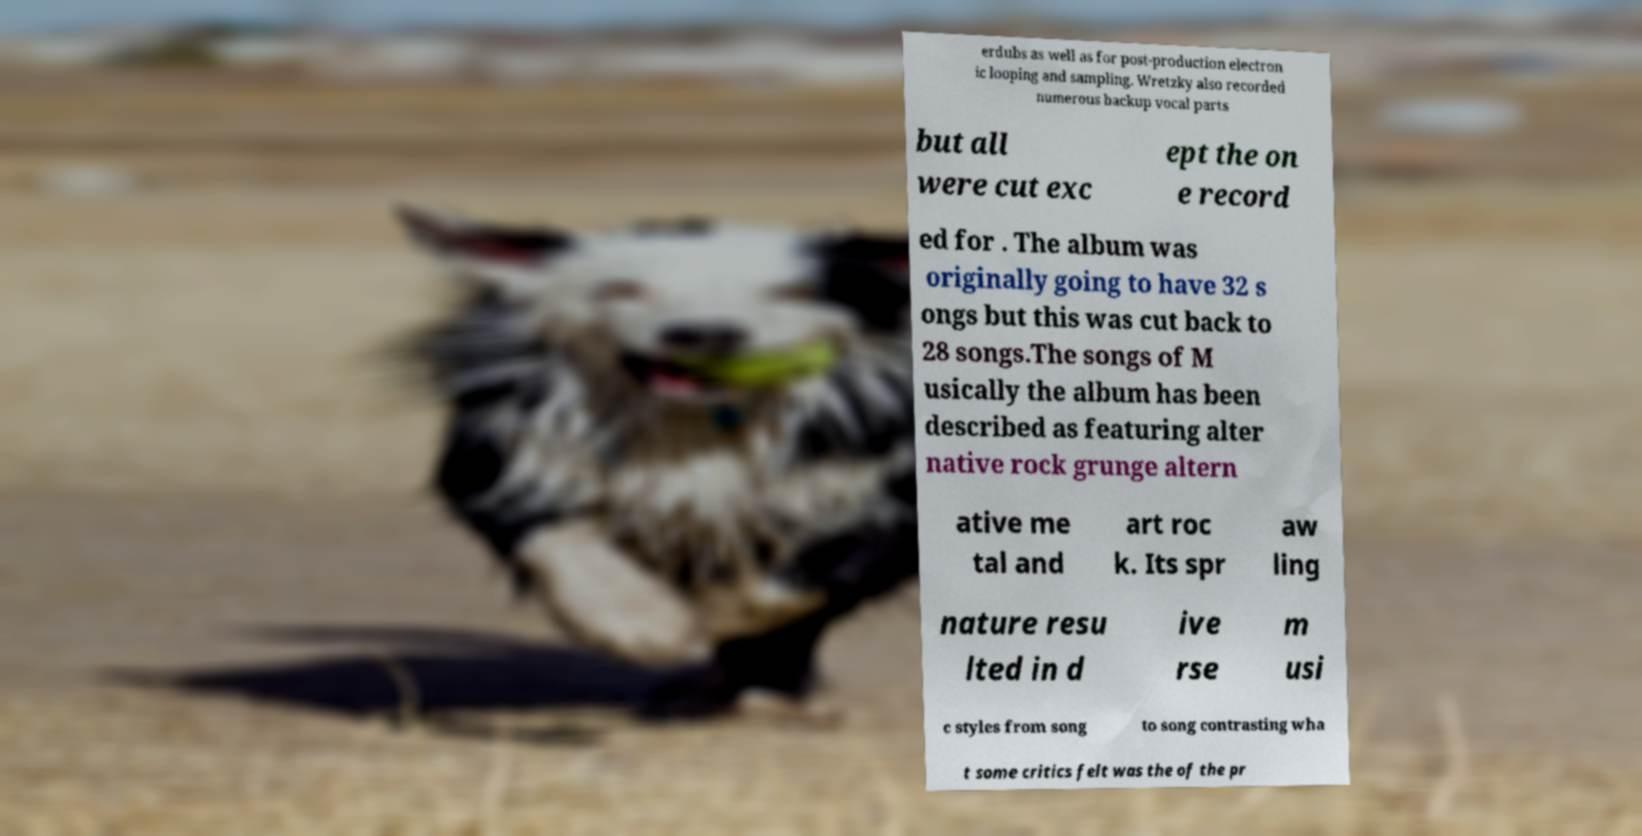Please identify and transcribe the text found in this image. erdubs as well as for post-production electron ic looping and sampling. Wretzky also recorded numerous backup vocal parts but all were cut exc ept the on e record ed for . The album was originally going to have 32 s ongs but this was cut back to 28 songs.The songs of M usically the album has been described as featuring alter native rock grunge altern ative me tal and art roc k. Its spr aw ling nature resu lted in d ive rse m usi c styles from song to song contrasting wha t some critics felt was the of the pr 